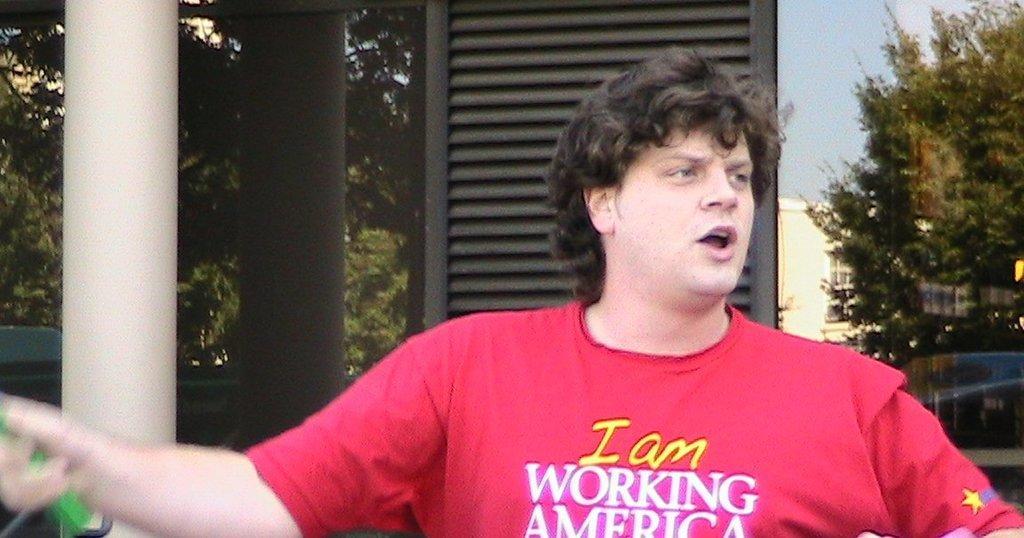Can you describe this image briefly? In this image we can see a person holding an object and in the background it looks like a building and there is a pillar in front of the building and we can see the reflection of trees, pillar and building on the glass. 